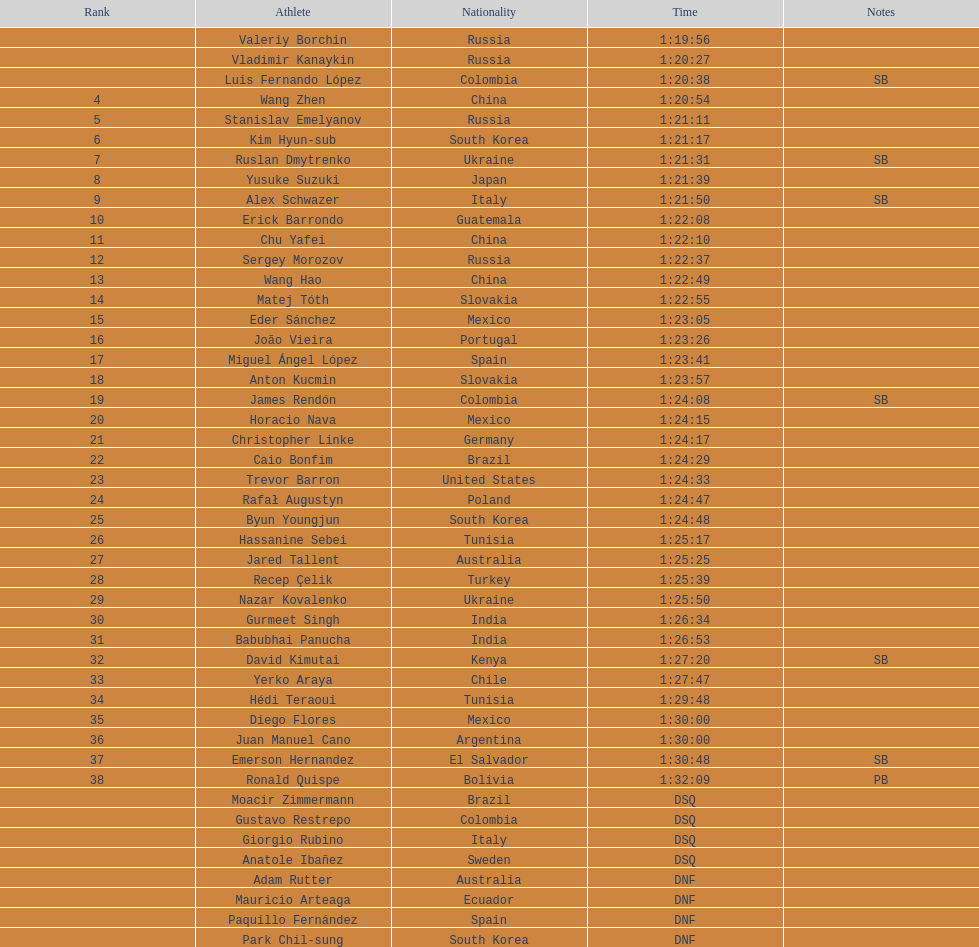How many competitors were from russia? 4. 